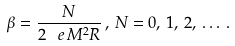<formula> <loc_0><loc_0><loc_500><loc_500>\beta = \frac { N } { 2 \, \ e \, M ^ { 2 } R } \, , \, N = 0 , \, 1 , \, 2 , \, \dots \, .</formula> 